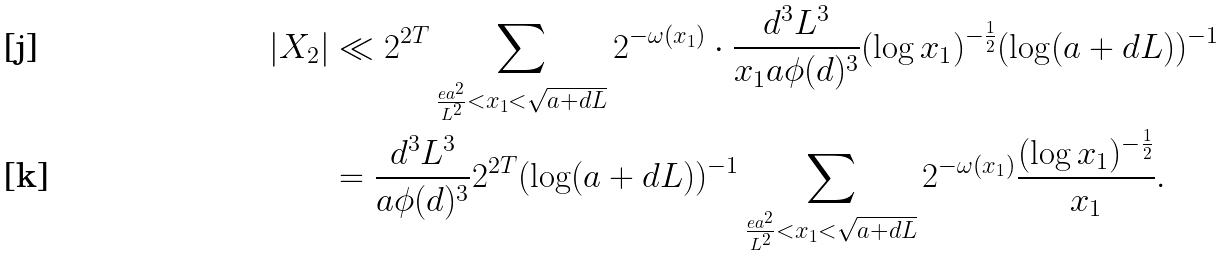<formula> <loc_0><loc_0><loc_500><loc_500>| X _ { 2 } | & \ll 2 ^ { 2 T } \sum _ { \frac { e a ^ { 2 } } { L ^ { 2 } } < x _ { 1 } < \sqrt { a + d L } } 2 ^ { - \omega ( x _ { 1 } ) } \cdot \frac { d ^ { 3 } L ^ { 3 } } { x _ { 1 } a \phi ( d ) ^ { 3 } } ( \log x _ { 1 } ) ^ { - \frac { 1 } { 2 } } ( \log ( a + d L ) ) ^ { - 1 } \\ & = \frac { d ^ { 3 } L ^ { 3 } } { a \phi ( d ) ^ { 3 } } 2 ^ { 2 T } ( \log ( a + d L ) ) ^ { - 1 } \sum _ { \frac { e a ^ { 2 } } { L ^ { 2 } } < x _ { 1 } < \sqrt { a + d L } } 2 ^ { - \omega ( x _ { 1 } ) } \frac { ( \log x _ { 1 } ) ^ { - \frac { 1 } { 2 } } } { x _ { 1 } } .</formula> 